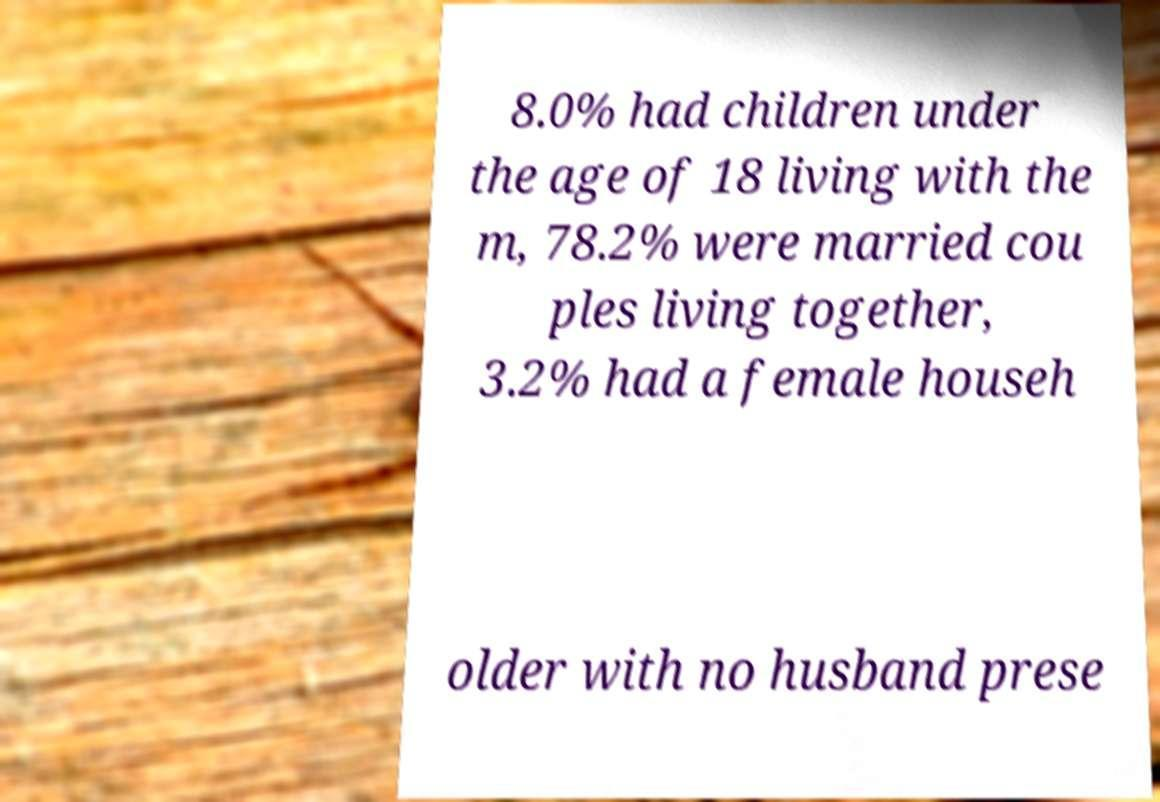Can you read and provide the text displayed in the image?This photo seems to have some interesting text. Can you extract and type it out for me? 8.0% had children under the age of 18 living with the m, 78.2% were married cou ples living together, 3.2% had a female househ older with no husband prese 